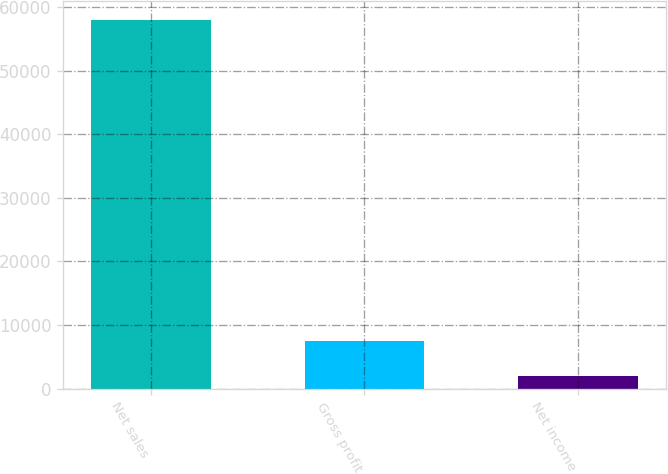Convert chart to OTSL. <chart><loc_0><loc_0><loc_500><loc_500><bar_chart><fcel>Net sales<fcel>Gross profit<fcel>Net income<nl><fcel>58068<fcel>7552.8<fcel>1940<nl></chart> 